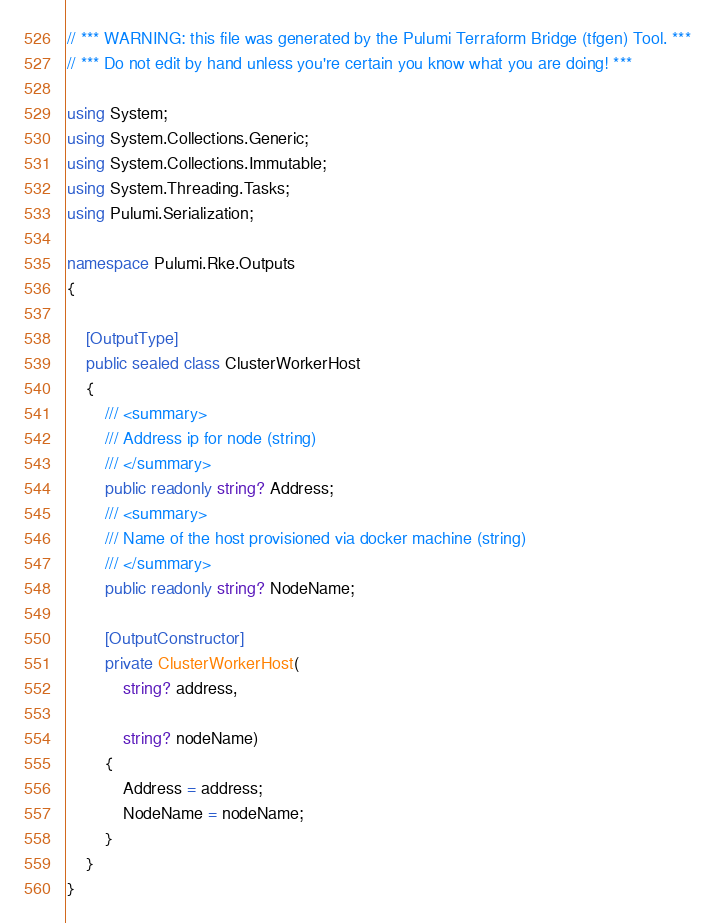<code> <loc_0><loc_0><loc_500><loc_500><_C#_>// *** WARNING: this file was generated by the Pulumi Terraform Bridge (tfgen) Tool. ***
// *** Do not edit by hand unless you're certain you know what you are doing! ***

using System;
using System.Collections.Generic;
using System.Collections.Immutable;
using System.Threading.Tasks;
using Pulumi.Serialization;

namespace Pulumi.Rke.Outputs
{

    [OutputType]
    public sealed class ClusterWorkerHost
    {
        /// <summary>
        /// Address ip for node (string)
        /// </summary>
        public readonly string? Address;
        /// <summary>
        /// Name of the host provisioned via docker machine (string)
        /// </summary>
        public readonly string? NodeName;

        [OutputConstructor]
        private ClusterWorkerHost(
            string? address,

            string? nodeName)
        {
            Address = address;
            NodeName = nodeName;
        }
    }
}
</code> 